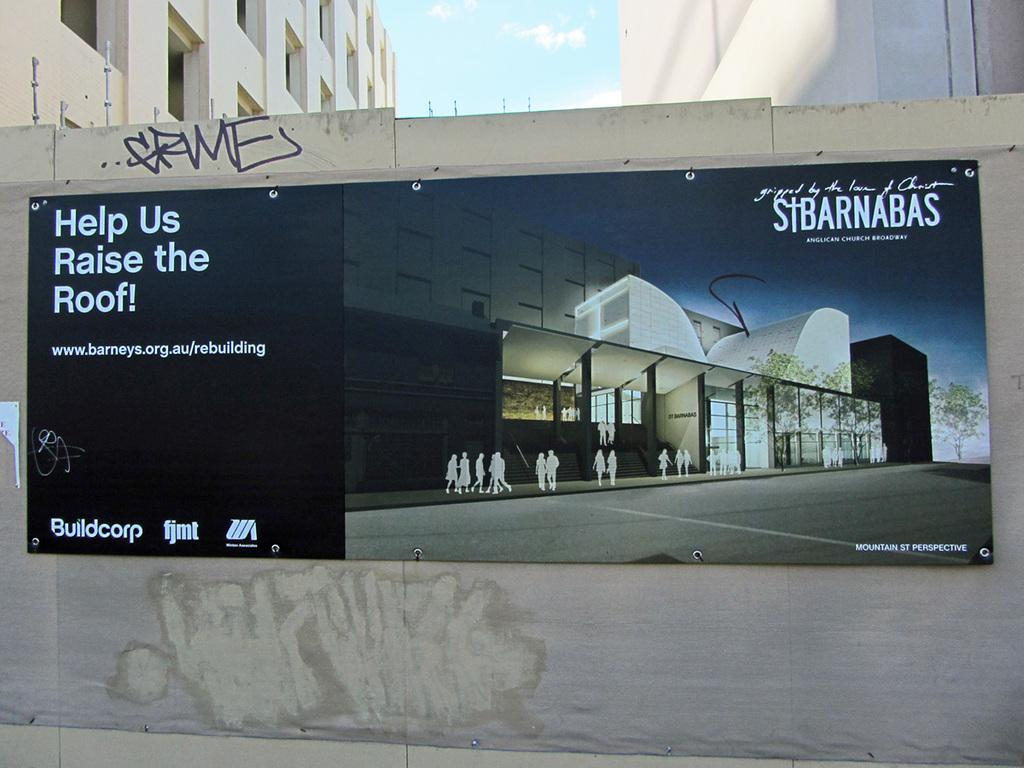<image>
Relay a brief, clear account of the picture shown. In order to help us raise the roof, go to www.barneys.org.au/rebuilding. 